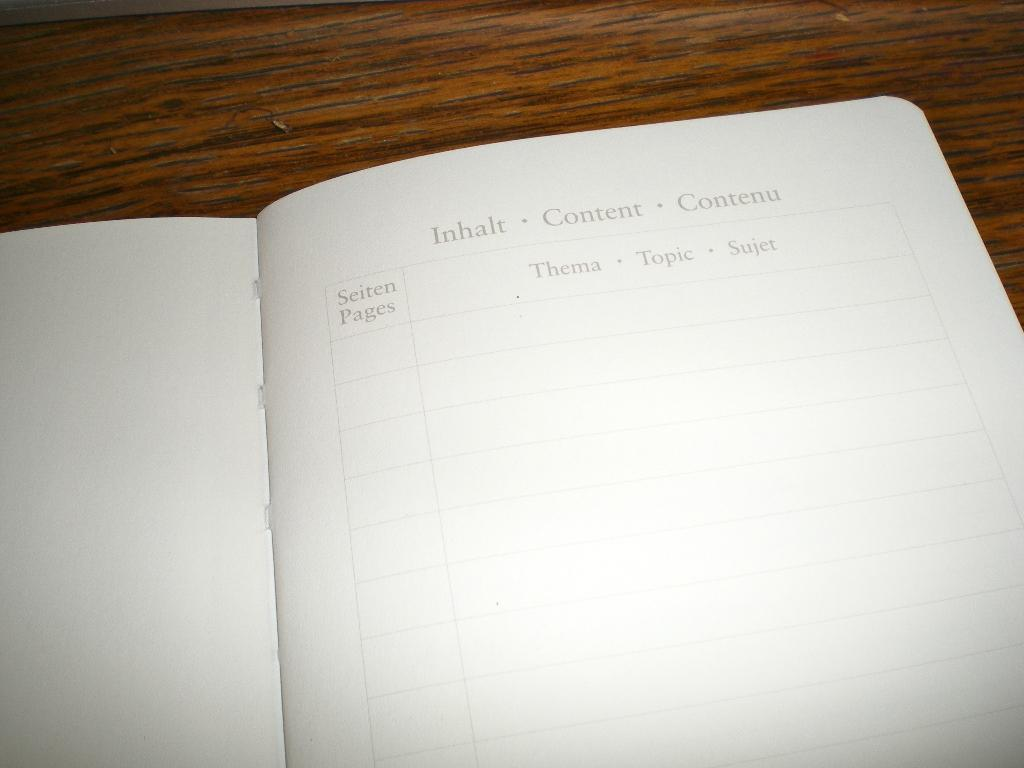<image>
Describe the image concisely. An open book with the word content in three languages 